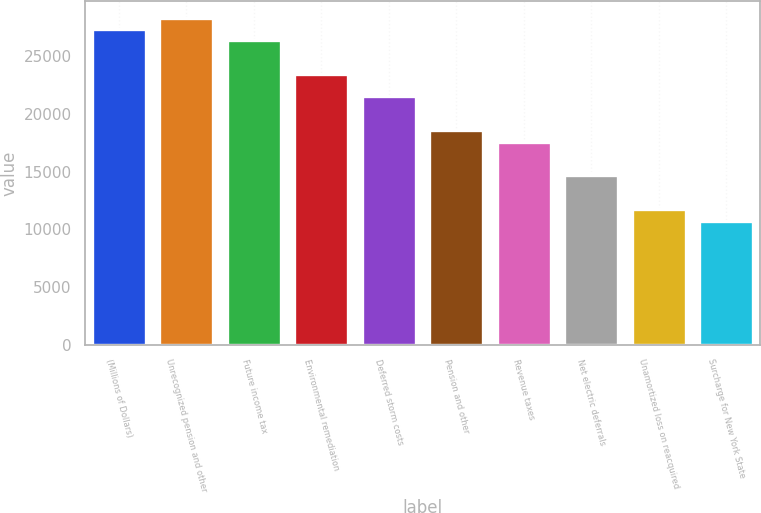Convert chart to OTSL. <chart><loc_0><loc_0><loc_500><loc_500><bar_chart><fcel>(Millions of Dollars)<fcel>Unrecognized pension and other<fcel>Future income tax<fcel>Environmental remediation<fcel>Deferred storm costs<fcel>Pension and other<fcel>Revenue taxes<fcel>Net electric deferrals<fcel>Unamortized loss on reacquired<fcel>Surcharge for New York State<nl><fcel>27372.2<fcel>28349.6<fcel>26394.8<fcel>23462.6<fcel>21507.8<fcel>18575.6<fcel>17598.2<fcel>14666<fcel>11733.8<fcel>10756.4<nl></chart> 